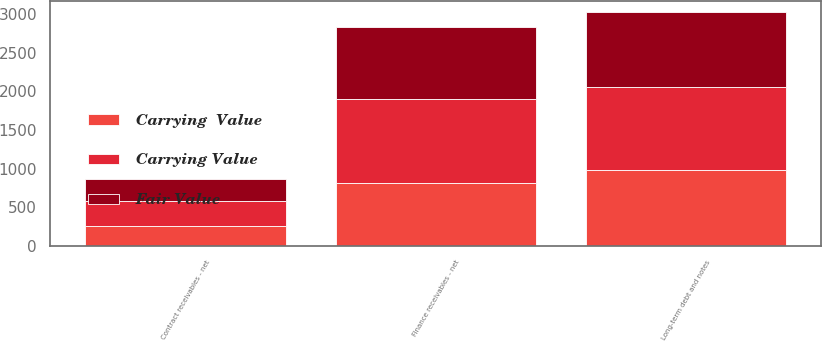Convert chart. <chart><loc_0><loc_0><loc_500><loc_500><stacked_bar_chart><ecel><fcel>Finance receivables - net<fcel>Contract receivables - net<fcel>Long-term debt and notes<nl><fcel>Fair Value<fcel>935.2<fcel>285.5<fcel>972<nl><fcel>Carrying Value<fcel>1084.1<fcel>326.7<fcel>1078.9<nl><fcel>Carrying  Value<fcel>817.7<fcel>257.1<fcel>975.6<nl></chart> 